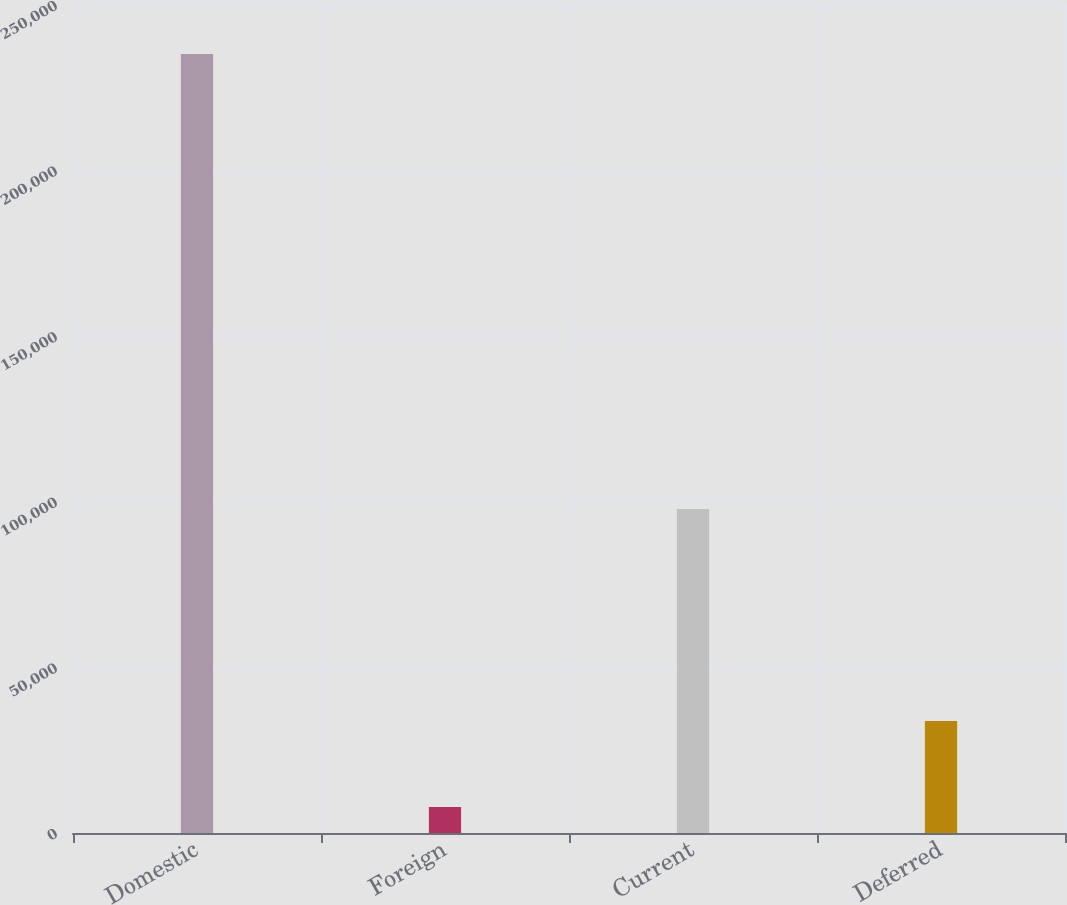<chart> <loc_0><loc_0><loc_500><loc_500><bar_chart><fcel>Domestic<fcel>Foreign<fcel>Current<fcel>Deferred<nl><fcel>235204<fcel>7818<fcel>97834<fcel>33808<nl></chart> 